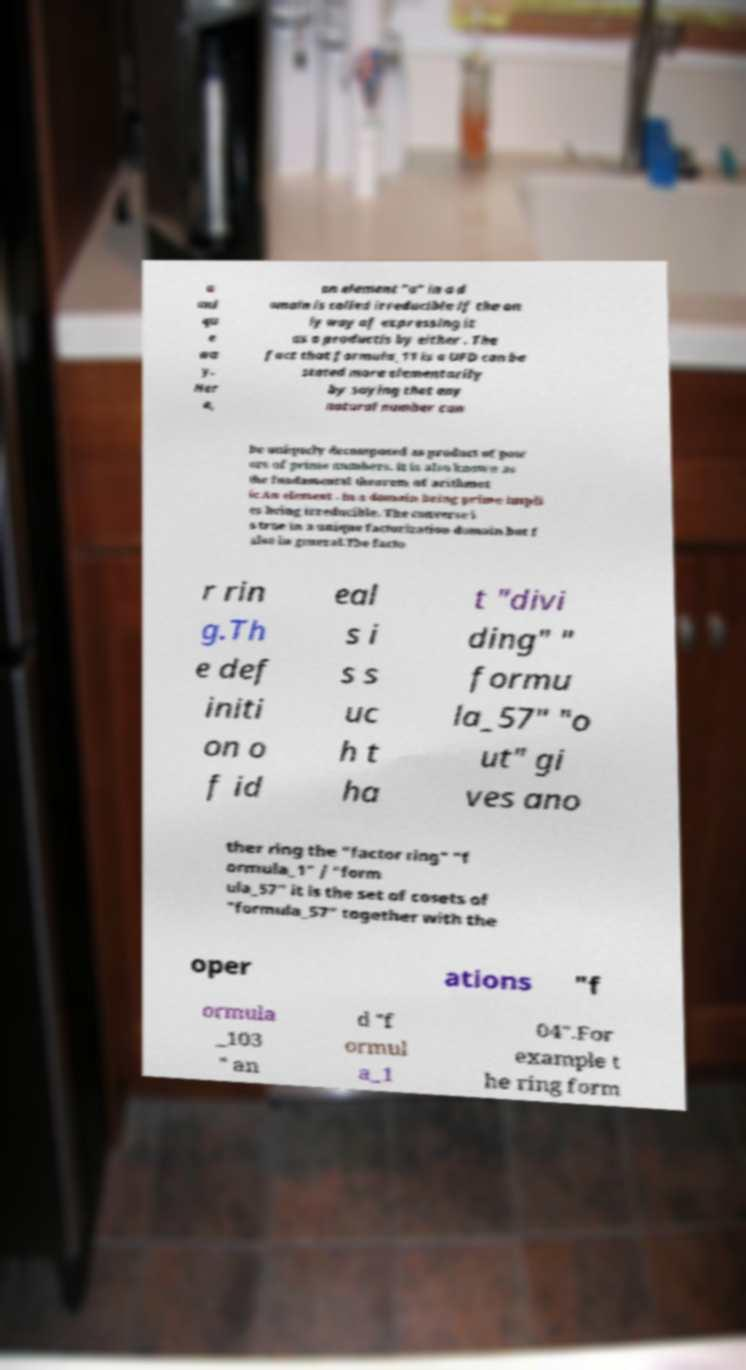Could you assist in decoding the text presented in this image and type it out clearly? a uni qu e wa y. Her e, an element "a" in a d omain is called irreducible if the on ly way of expressing it as a productis by either . The fact that formula_11 is a UFD can be stated more elementarily by saying that any natural number can be uniquely decomposed as product of pow ers of prime numbers. It is also known as the fundamental theorem of arithmet ic.An element . In a domain being prime impli es being irreducible. The converse i s true in a unique factorization domain but f alse in general.The facto r rin g.Th e def initi on o f id eal s i s s uc h t ha t "divi ding" " formu la_57" "o ut" gi ves ano ther ring the "factor ring" "f ormula_1" / "form ula_57" it is the set of cosets of "formula_57" together with the oper ations "f ormula _103 " an d "f ormul a_1 04".For example t he ring form 